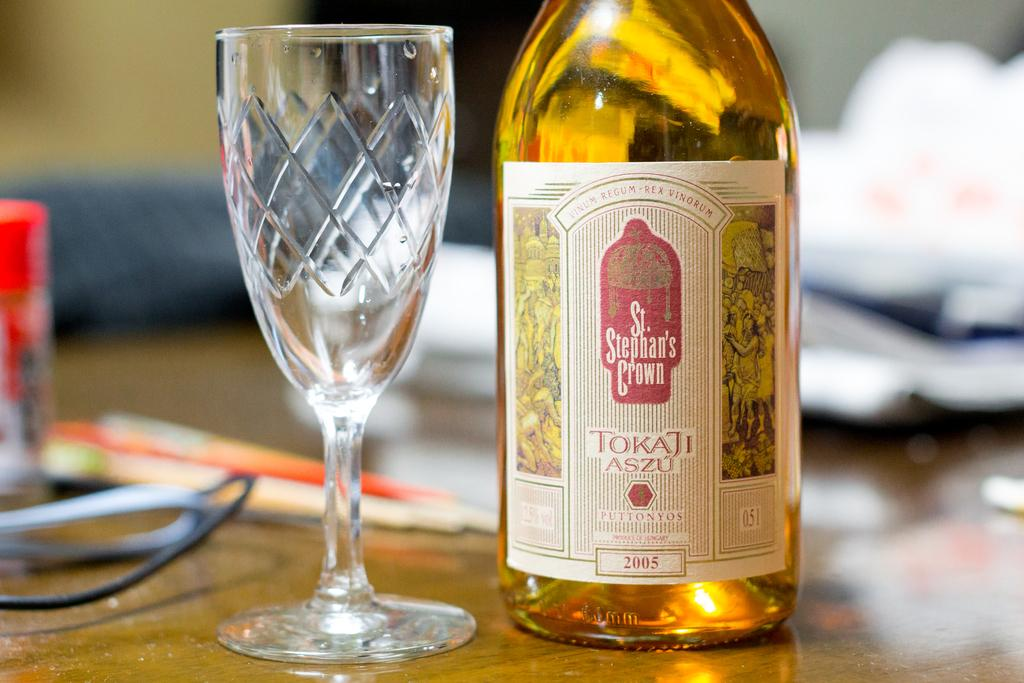What type of container is visible in the image? There is a bottle in the image. What other type of container is present in the image? There is a glass in the image. What can be seen in the background of the image? There is a wall in the background of the image. How much water is in the bottle in the image? The amount of water in the bottle cannot be determined from the image, as the contents of the bottle are not visible. 